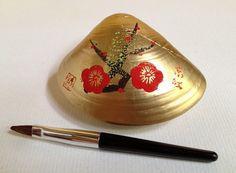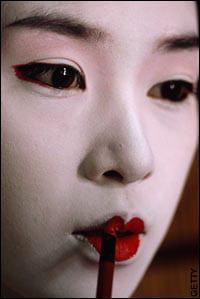The first image is the image on the left, the second image is the image on the right. Given the left and right images, does the statement "An image shows a woman in pale geisha makeup, with pink flowers in her upswept hair." hold true? Answer yes or no. No. The first image is the image on the left, the second image is the image on the right. Given the left and right images, does the statement "A geisha is wearing large flowers on her hair and is not looking at the camera." hold true? Answer yes or no. No. 